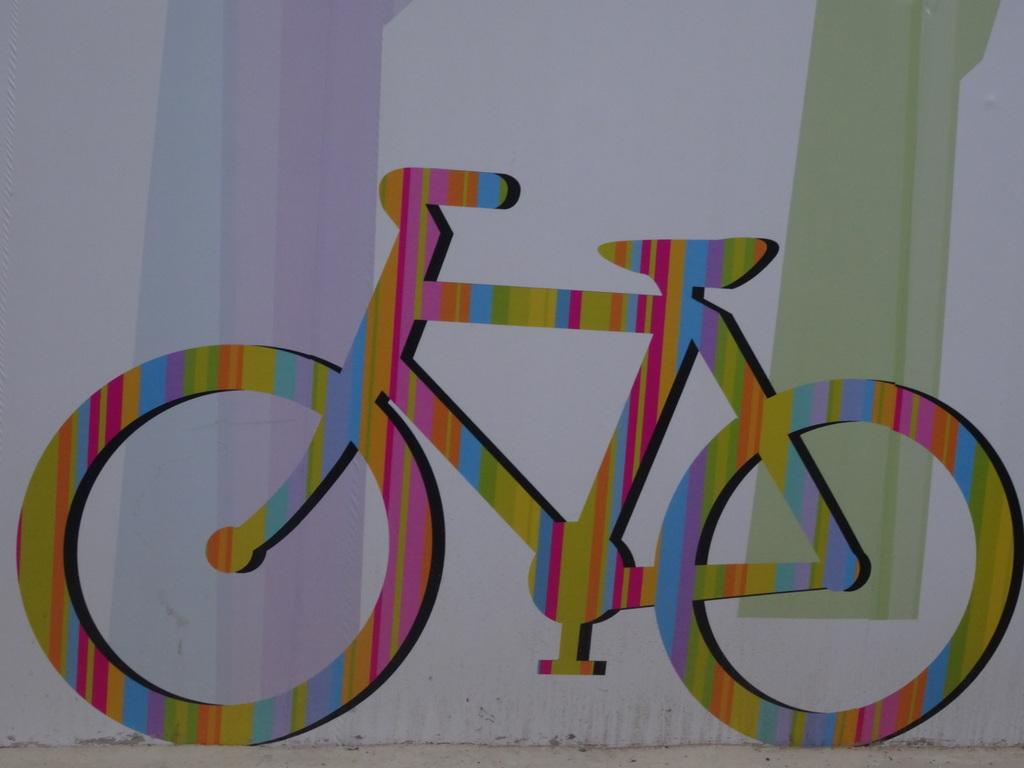What is depicted on the wall in the image? There is a painting on the wall in the image. What is the main subject of the painting? The painting contains a cycle. How are the colors represented in the cycle of the painting? The cycle has different colors in the painting. What type of quartz can be seen in the painting? There is no quartz present in the painting; it features a cycle with different colors. How does the weather affect the waves in the painting? There are no waves depicted in the painting, as it features a cycle with different colors. 